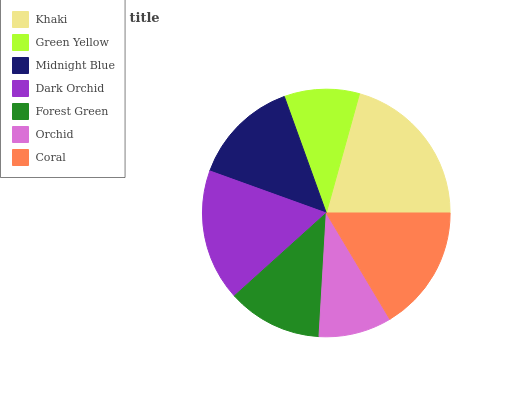Is Orchid the minimum?
Answer yes or no. Yes. Is Khaki the maximum?
Answer yes or no. Yes. Is Green Yellow the minimum?
Answer yes or no. No. Is Green Yellow the maximum?
Answer yes or no. No. Is Khaki greater than Green Yellow?
Answer yes or no. Yes. Is Green Yellow less than Khaki?
Answer yes or no. Yes. Is Green Yellow greater than Khaki?
Answer yes or no. No. Is Khaki less than Green Yellow?
Answer yes or no. No. Is Midnight Blue the high median?
Answer yes or no. Yes. Is Midnight Blue the low median?
Answer yes or no. Yes. Is Green Yellow the high median?
Answer yes or no. No. Is Khaki the low median?
Answer yes or no. No. 